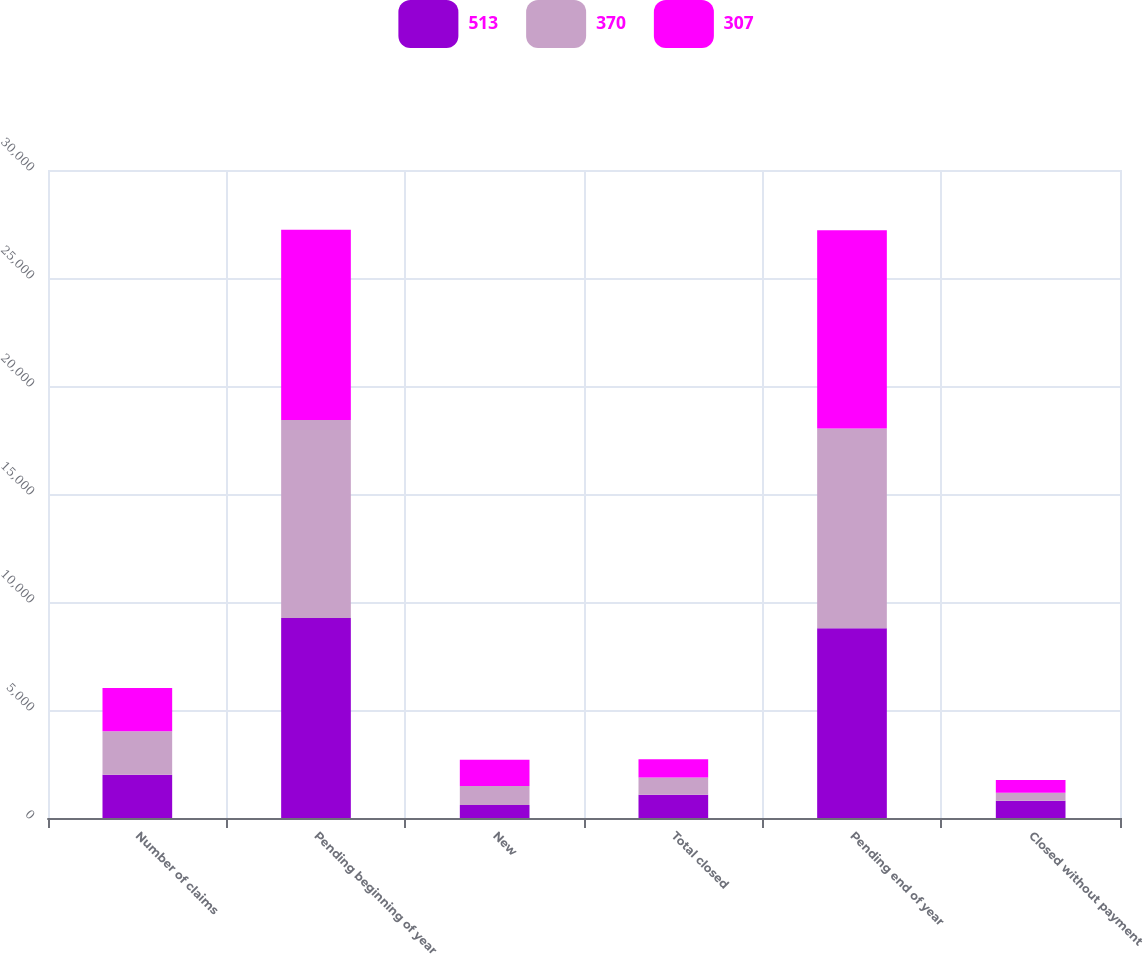Convert chart. <chart><loc_0><loc_0><loc_500><loc_500><stacked_bar_chart><ecel><fcel>Number of claims<fcel>Pending beginning of year<fcel>New<fcel>Total closed<fcel>Pending end of year<fcel>Closed without payment<nl><fcel>513<fcel>2008<fcel>9256<fcel>601<fcel>1077<fcel>8780<fcel>800<nl><fcel>370<fcel>2007<fcel>9175<fcel>876<fcel>795<fcel>9256<fcel>364<nl><fcel>307<fcel>2006<fcel>8806<fcel>1220<fcel>851<fcel>9175<fcel>596<nl></chart> 